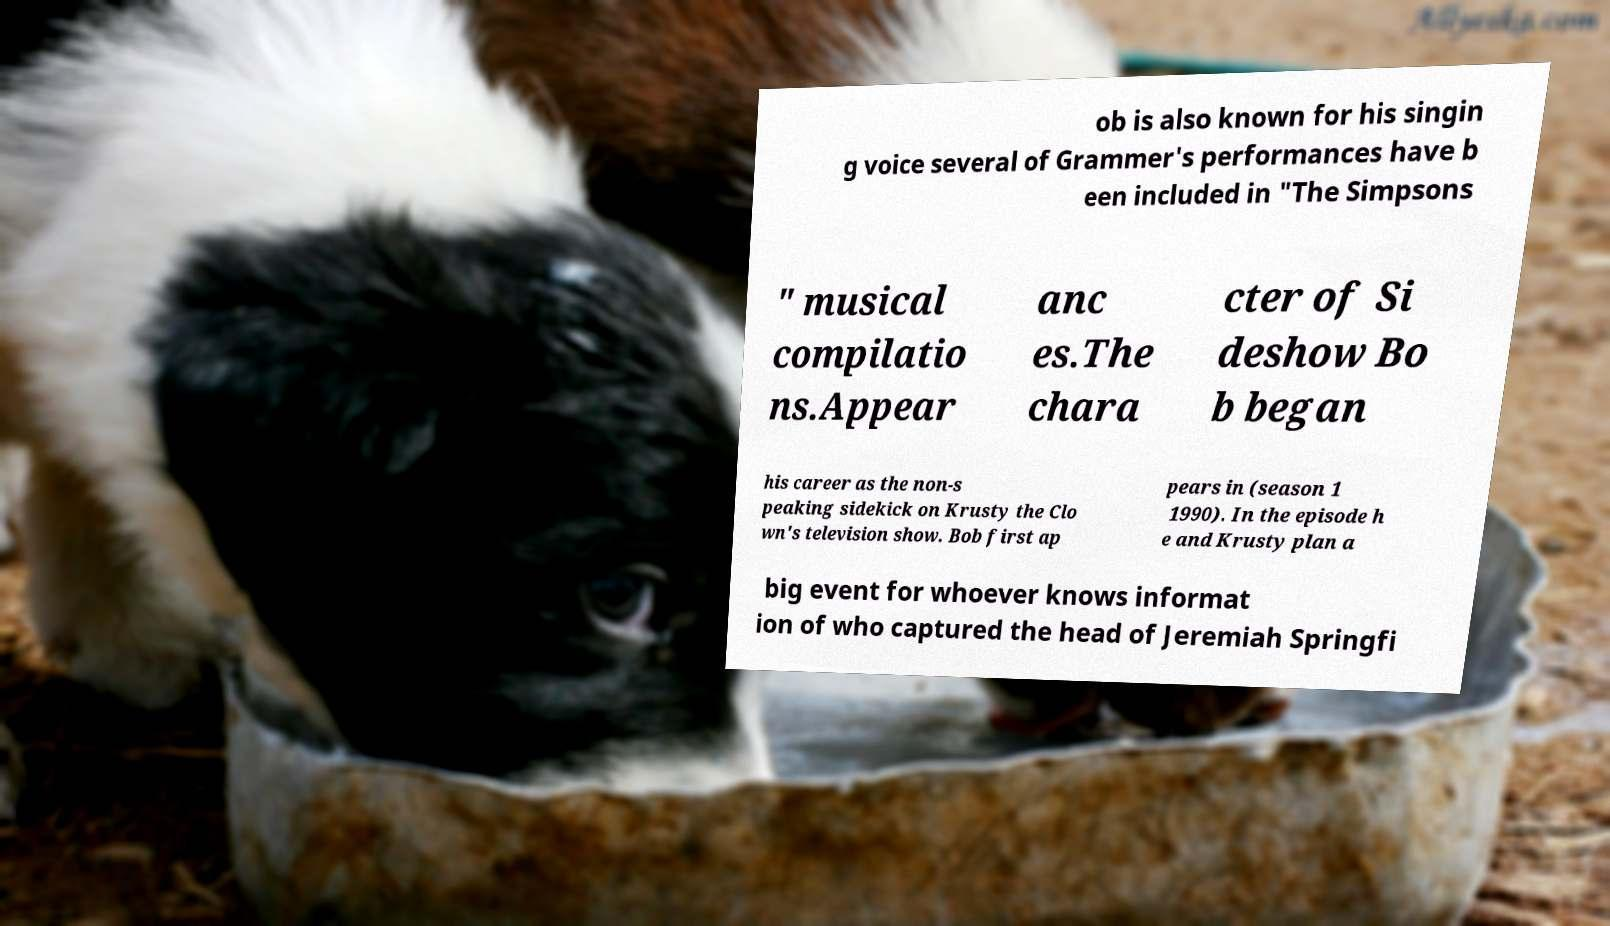There's text embedded in this image that I need extracted. Can you transcribe it verbatim? ob is also known for his singin g voice several of Grammer's performances have b een included in "The Simpsons " musical compilatio ns.Appear anc es.The chara cter of Si deshow Bo b began his career as the non-s peaking sidekick on Krusty the Clo wn's television show. Bob first ap pears in (season 1 1990). In the episode h e and Krusty plan a big event for whoever knows informat ion of who captured the head of Jeremiah Springfi 